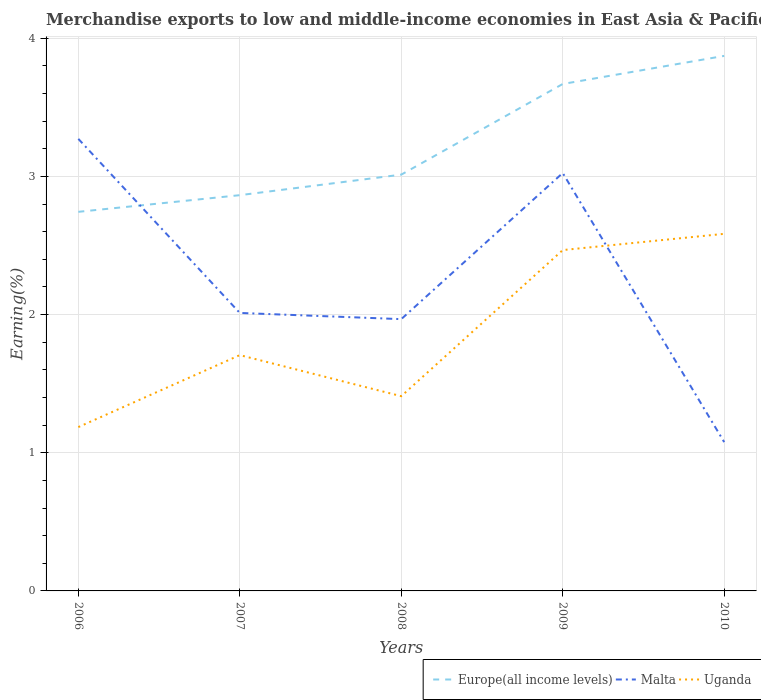How many different coloured lines are there?
Your answer should be compact. 3. Does the line corresponding to Uganda intersect with the line corresponding to Europe(all income levels)?
Offer a very short reply. No. Across all years, what is the maximum percentage of amount earned from merchandise exports in Europe(all income levels)?
Offer a terse response. 2.74. In which year was the percentage of amount earned from merchandise exports in Uganda maximum?
Offer a very short reply. 2006. What is the total percentage of amount earned from merchandise exports in Malta in the graph?
Provide a short and direct response. -1.06. What is the difference between the highest and the second highest percentage of amount earned from merchandise exports in Europe(all income levels)?
Make the answer very short. 1.13. What is the difference between the highest and the lowest percentage of amount earned from merchandise exports in Uganda?
Provide a succinct answer. 2. How many lines are there?
Ensure brevity in your answer.  3. Are the values on the major ticks of Y-axis written in scientific E-notation?
Your response must be concise. No. Where does the legend appear in the graph?
Offer a terse response. Bottom right. How many legend labels are there?
Your answer should be compact. 3. How are the legend labels stacked?
Offer a very short reply. Horizontal. What is the title of the graph?
Ensure brevity in your answer.  Merchandise exports to low and middle-income economies in East Asia & Pacific. What is the label or title of the X-axis?
Keep it short and to the point. Years. What is the label or title of the Y-axis?
Provide a succinct answer. Earning(%). What is the Earning(%) in Europe(all income levels) in 2006?
Give a very brief answer. 2.74. What is the Earning(%) of Malta in 2006?
Ensure brevity in your answer.  3.27. What is the Earning(%) in Uganda in 2006?
Provide a succinct answer. 1.19. What is the Earning(%) in Europe(all income levels) in 2007?
Offer a terse response. 2.86. What is the Earning(%) in Malta in 2007?
Offer a very short reply. 2.01. What is the Earning(%) in Uganda in 2007?
Your response must be concise. 1.71. What is the Earning(%) in Europe(all income levels) in 2008?
Your answer should be very brief. 3.01. What is the Earning(%) in Malta in 2008?
Give a very brief answer. 1.97. What is the Earning(%) of Uganda in 2008?
Your response must be concise. 1.41. What is the Earning(%) in Europe(all income levels) in 2009?
Your answer should be very brief. 3.67. What is the Earning(%) in Malta in 2009?
Ensure brevity in your answer.  3.02. What is the Earning(%) in Uganda in 2009?
Your answer should be very brief. 2.47. What is the Earning(%) of Europe(all income levels) in 2010?
Provide a short and direct response. 3.87. What is the Earning(%) of Malta in 2010?
Provide a short and direct response. 1.08. What is the Earning(%) in Uganda in 2010?
Offer a terse response. 2.58. Across all years, what is the maximum Earning(%) of Europe(all income levels)?
Make the answer very short. 3.87. Across all years, what is the maximum Earning(%) in Malta?
Offer a terse response. 3.27. Across all years, what is the maximum Earning(%) in Uganda?
Keep it short and to the point. 2.58. Across all years, what is the minimum Earning(%) in Europe(all income levels)?
Offer a very short reply. 2.74. Across all years, what is the minimum Earning(%) of Malta?
Make the answer very short. 1.08. Across all years, what is the minimum Earning(%) of Uganda?
Provide a short and direct response. 1.19. What is the total Earning(%) in Europe(all income levels) in the graph?
Provide a succinct answer. 16.16. What is the total Earning(%) in Malta in the graph?
Give a very brief answer. 11.35. What is the total Earning(%) of Uganda in the graph?
Make the answer very short. 9.35. What is the difference between the Earning(%) in Europe(all income levels) in 2006 and that in 2007?
Provide a short and direct response. -0.12. What is the difference between the Earning(%) of Malta in 2006 and that in 2007?
Make the answer very short. 1.26. What is the difference between the Earning(%) of Uganda in 2006 and that in 2007?
Ensure brevity in your answer.  -0.52. What is the difference between the Earning(%) in Europe(all income levels) in 2006 and that in 2008?
Offer a terse response. -0.27. What is the difference between the Earning(%) in Malta in 2006 and that in 2008?
Give a very brief answer. 1.3. What is the difference between the Earning(%) of Uganda in 2006 and that in 2008?
Your answer should be compact. -0.22. What is the difference between the Earning(%) in Europe(all income levels) in 2006 and that in 2009?
Offer a very short reply. -0.93. What is the difference between the Earning(%) of Malta in 2006 and that in 2009?
Your response must be concise. 0.25. What is the difference between the Earning(%) of Uganda in 2006 and that in 2009?
Keep it short and to the point. -1.28. What is the difference between the Earning(%) in Europe(all income levels) in 2006 and that in 2010?
Your answer should be very brief. -1.13. What is the difference between the Earning(%) of Malta in 2006 and that in 2010?
Provide a succinct answer. 2.19. What is the difference between the Earning(%) in Uganda in 2006 and that in 2010?
Ensure brevity in your answer.  -1.4. What is the difference between the Earning(%) of Europe(all income levels) in 2007 and that in 2008?
Your answer should be very brief. -0.15. What is the difference between the Earning(%) of Malta in 2007 and that in 2008?
Keep it short and to the point. 0.04. What is the difference between the Earning(%) in Uganda in 2007 and that in 2008?
Your response must be concise. 0.3. What is the difference between the Earning(%) of Europe(all income levels) in 2007 and that in 2009?
Your response must be concise. -0.8. What is the difference between the Earning(%) in Malta in 2007 and that in 2009?
Make the answer very short. -1.01. What is the difference between the Earning(%) of Uganda in 2007 and that in 2009?
Offer a very short reply. -0.76. What is the difference between the Earning(%) of Europe(all income levels) in 2007 and that in 2010?
Offer a very short reply. -1.01. What is the difference between the Earning(%) of Malta in 2007 and that in 2010?
Your response must be concise. 0.93. What is the difference between the Earning(%) in Uganda in 2007 and that in 2010?
Your answer should be compact. -0.88. What is the difference between the Earning(%) of Europe(all income levels) in 2008 and that in 2009?
Give a very brief answer. -0.66. What is the difference between the Earning(%) of Malta in 2008 and that in 2009?
Provide a succinct answer. -1.06. What is the difference between the Earning(%) of Uganda in 2008 and that in 2009?
Give a very brief answer. -1.06. What is the difference between the Earning(%) in Europe(all income levels) in 2008 and that in 2010?
Ensure brevity in your answer.  -0.86. What is the difference between the Earning(%) in Malta in 2008 and that in 2010?
Your response must be concise. 0.89. What is the difference between the Earning(%) in Uganda in 2008 and that in 2010?
Give a very brief answer. -1.17. What is the difference between the Earning(%) in Europe(all income levels) in 2009 and that in 2010?
Give a very brief answer. -0.2. What is the difference between the Earning(%) of Malta in 2009 and that in 2010?
Your answer should be compact. 1.95. What is the difference between the Earning(%) of Uganda in 2009 and that in 2010?
Offer a terse response. -0.12. What is the difference between the Earning(%) in Europe(all income levels) in 2006 and the Earning(%) in Malta in 2007?
Your answer should be compact. 0.73. What is the difference between the Earning(%) in Europe(all income levels) in 2006 and the Earning(%) in Uganda in 2007?
Offer a terse response. 1.04. What is the difference between the Earning(%) in Malta in 2006 and the Earning(%) in Uganda in 2007?
Give a very brief answer. 1.56. What is the difference between the Earning(%) in Europe(all income levels) in 2006 and the Earning(%) in Malta in 2008?
Your answer should be compact. 0.78. What is the difference between the Earning(%) of Europe(all income levels) in 2006 and the Earning(%) of Uganda in 2008?
Your answer should be very brief. 1.33. What is the difference between the Earning(%) of Malta in 2006 and the Earning(%) of Uganda in 2008?
Keep it short and to the point. 1.86. What is the difference between the Earning(%) of Europe(all income levels) in 2006 and the Earning(%) of Malta in 2009?
Provide a succinct answer. -0.28. What is the difference between the Earning(%) of Europe(all income levels) in 2006 and the Earning(%) of Uganda in 2009?
Provide a succinct answer. 0.28. What is the difference between the Earning(%) in Malta in 2006 and the Earning(%) in Uganda in 2009?
Offer a very short reply. 0.8. What is the difference between the Earning(%) of Europe(all income levels) in 2006 and the Earning(%) of Malta in 2010?
Keep it short and to the point. 1.67. What is the difference between the Earning(%) in Europe(all income levels) in 2006 and the Earning(%) in Uganda in 2010?
Make the answer very short. 0.16. What is the difference between the Earning(%) of Malta in 2006 and the Earning(%) of Uganda in 2010?
Keep it short and to the point. 0.69. What is the difference between the Earning(%) of Europe(all income levels) in 2007 and the Earning(%) of Malta in 2008?
Give a very brief answer. 0.9. What is the difference between the Earning(%) of Europe(all income levels) in 2007 and the Earning(%) of Uganda in 2008?
Make the answer very short. 1.45. What is the difference between the Earning(%) in Malta in 2007 and the Earning(%) in Uganda in 2008?
Keep it short and to the point. 0.6. What is the difference between the Earning(%) in Europe(all income levels) in 2007 and the Earning(%) in Malta in 2009?
Keep it short and to the point. -0.16. What is the difference between the Earning(%) in Europe(all income levels) in 2007 and the Earning(%) in Uganda in 2009?
Provide a short and direct response. 0.4. What is the difference between the Earning(%) of Malta in 2007 and the Earning(%) of Uganda in 2009?
Offer a very short reply. -0.46. What is the difference between the Earning(%) of Europe(all income levels) in 2007 and the Earning(%) of Malta in 2010?
Offer a terse response. 1.79. What is the difference between the Earning(%) in Europe(all income levels) in 2007 and the Earning(%) in Uganda in 2010?
Give a very brief answer. 0.28. What is the difference between the Earning(%) in Malta in 2007 and the Earning(%) in Uganda in 2010?
Provide a short and direct response. -0.57. What is the difference between the Earning(%) in Europe(all income levels) in 2008 and the Earning(%) in Malta in 2009?
Provide a short and direct response. -0.01. What is the difference between the Earning(%) in Europe(all income levels) in 2008 and the Earning(%) in Uganda in 2009?
Your answer should be compact. 0.55. What is the difference between the Earning(%) of Malta in 2008 and the Earning(%) of Uganda in 2009?
Ensure brevity in your answer.  -0.5. What is the difference between the Earning(%) in Europe(all income levels) in 2008 and the Earning(%) in Malta in 2010?
Your answer should be very brief. 1.94. What is the difference between the Earning(%) of Europe(all income levels) in 2008 and the Earning(%) of Uganda in 2010?
Offer a very short reply. 0.43. What is the difference between the Earning(%) of Malta in 2008 and the Earning(%) of Uganda in 2010?
Provide a short and direct response. -0.62. What is the difference between the Earning(%) of Europe(all income levels) in 2009 and the Earning(%) of Malta in 2010?
Offer a terse response. 2.59. What is the difference between the Earning(%) in Europe(all income levels) in 2009 and the Earning(%) in Uganda in 2010?
Ensure brevity in your answer.  1.08. What is the difference between the Earning(%) of Malta in 2009 and the Earning(%) of Uganda in 2010?
Your answer should be very brief. 0.44. What is the average Earning(%) of Europe(all income levels) per year?
Make the answer very short. 3.23. What is the average Earning(%) in Malta per year?
Provide a short and direct response. 2.27. What is the average Earning(%) in Uganda per year?
Make the answer very short. 1.87. In the year 2006, what is the difference between the Earning(%) in Europe(all income levels) and Earning(%) in Malta?
Make the answer very short. -0.53. In the year 2006, what is the difference between the Earning(%) in Europe(all income levels) and Earning(%) in Uganda?
Make the answer very short. 1.56. In the year 2006, what is the difference between the Earning(%) of Malta and Earning(%) of Uganda?
Your answer should be very brief. 2.09. In the year 2007, what is the difference between the Earning(%) in Europe(all income levels) and Earning(%) in Malta?
Offer a terse response. 0.85. In the year 2007, what is the difference between the Earning(%) in Europe(all income levels) and Earning(%) in Uganda?
Give a very brief answer. 1.16. In the year 2007, what is the difference between the Earning(%) of Malta and Earning(%) of Uganda?
Keep it short and to the point. 0.31. In the year 2008, what is the difference between the Earning(%) in Europe(all income levels) and Earning(%) in Malta?
Provide a short and direct response. 1.05. In the year 2008, what is the difference between the Earning(%) in Europe(all income levels) and Earning(%) in Uganda?
Give a very brief answer. 1.6. In the year 2008, what is the difference between the Earning(%) in Malta and Earning(%) in Uganda?
Your answer should be very brief. 0.56. In the year 2009, what is the difference between the Earning(%) in Europe(all income levels) and Earning(%) in Malta?
Provide a short and direct response. 0.64. In the year 2009, what is the difference between the Earning(%) in Europe(all income levels) and Earning(%) in Uganda?
Offer a very short reply. 1.2. In the year 2009, what is the difference between the Earning(%) of Malta and Earning(%) of Uganda?
Your answer should be very brief. 0.56. In the year 2010, what is the difference between the Earning(%) in Europe(all income levels) and Earning(%) in Malta?
Your answer should be compact. 2.79. In the year 2010, what is the difference between the Earning(%) of Europe(all income levels) and Earning(%) of Uganda?
Provide a succinct answer. 1.29. In the year 2010, what is the difference between the Earning(%) in Malta and Earning(%) in Uganda?
Give a very brief answer. -1.51. What is the ratio of the Earning(%) of Europe(all income levels) in 2006 to that in 2007?
Offer a terse response. 0.96. What is the ratio of the Earning(%) of Malta in 2006 to that in 2007?
Your response must be concise. 1.63. What is the ratio of the Earning(%) in Uganda in 2006 to that in 2007?
Ensure brevity in your answer.  0.69. What is the ratio of the Earning(%) in Europe(all income levels) in 2006 to that in 2008?
Provide a short and direct response. 0.91. What is the ratio of the Earning(%) in Malta in 2006 to that in 2008?
Offer a terse response. 1.66. What is the ratio of the Earning(%) of Uganda in 2006 to that in 2008?
Offer a very short reply. 0.84. What is the ratio of the Earning(%) of Europe(all income levels) in 2006 to that in 2009?
Your answer should be very brief. 0.75. What is the ratio of the Earning(%) in Malta in 2006 to that in 2009?
Your response must be concise. 1.08. What is the ratio of the Earning(%) in Uganda in 2006 to that in 2009?
Your response must be concise. 0.48. What is the ratio of the Earning(%) in Europe(all income levels) in 2006 to that in 2010?
Provide a short and direct response. 0.71. What is the ratio of the Earning(%) in Malta in 2006 to that in 2010?
Make the answer very short. 3.04. What is the ratio of the Earning(%) in Uganda in 2006 to that in 2010?
Ensure brevity in your answer.  0.46. What is the ratio of the Earning(%) in Europe(all income levels) in 2007 to that in 2008?
Your response must be concise. 0.95. What is the ratio of the Earning(%) in Malta in 2007 to that in 2008?
Offer a terse response. 1.02. What is the ratio of the Earning(%) in Uganda in 2007 to that in 2008?
Give a very brief answer. 1.21. What is the ratio of the Earning(%) in Europe(all income levels) in 2007 to that in 2009?
Make the answer very short. 0.78. What is the ratio of the Earning(%) of Malta in 2007 to that in 2009?
Your answer should be very brief. 0.67. What is the ratio of the Earning(%) in Uganda in 2007 to that in 2009?
Your answer should be very brief. 0.69. What is the ratio of the Earning(%) in Europe(all income levels) in 2007 to that in 2010?
Offer a terse response. 0.74. What is the ratio of the Earning(%) of Malta in 2007 to that in 2010?
Your answer should be very brief. 1.87. What is the ratio of the Earning(%) of Uganda in 2007 to that in 2010?
Make the answer very short. 0.66. What is the ratio of the Earning(%) in Europe(all income levels) in 2008 to that in 2009?
Offer a terse response. 0.82. What is the ratio of the Earning(%) of Malta in 2008 to that in 2009?
Your answer should be compact. 0.65. What is the ratio of the Earning(%) in Uganda in 2008 to that in 2009?
Make the answer very short. 0.57. What is the ratio of the Earning(%) of Europe(all income levels) in 2008 to that in 2010?
Ensure brevity in your answer.  0.78. What is the ratio of the Earning(%) of Malta in 2008 to that in 2010?
Provide a succinct answer. 1.83. What is the ratio of the Earning(%) of Uganda in 2008 to that in 2010?
Your response must be concise. 0.55. What is the ratio of the Earning(%) of Europe(all income levels) in 2009 to that in 2010?
Keep it short and to the point. 0.95. What is the ratio of the Earning(%) in Malta in 2009 to that in 2010?
Your answer should be compact. 2.81. What is the ratio of the Earning(%) of Uganda in 2009 to that in 2010?
Make the answer very short. 0.95. What is the difference between the highest and the second highest Earning(%) in Europe(all income levels)?
Your answer should be very brief. 0.2. What is the difference between the highest and the second highest Earning(%) of Malta?
Offer a very short reply. 0.25. What is the difference between the highest and the second highest Earning(%) of Uganda?
Give a very brief answer. 0.12. What is the difference between the highest and the lowest Earning(%) in Europe(all income levels)?
Ensure brevity in your answer.  1.13. What is the difference between the highest and the lowest Earning(%) of Malta?
Provide a succinct answer. 2.19. What is the difference between the highest and the lowest Earning(%) in Uganda?
Ensure brevity in your answer.  1.4. 